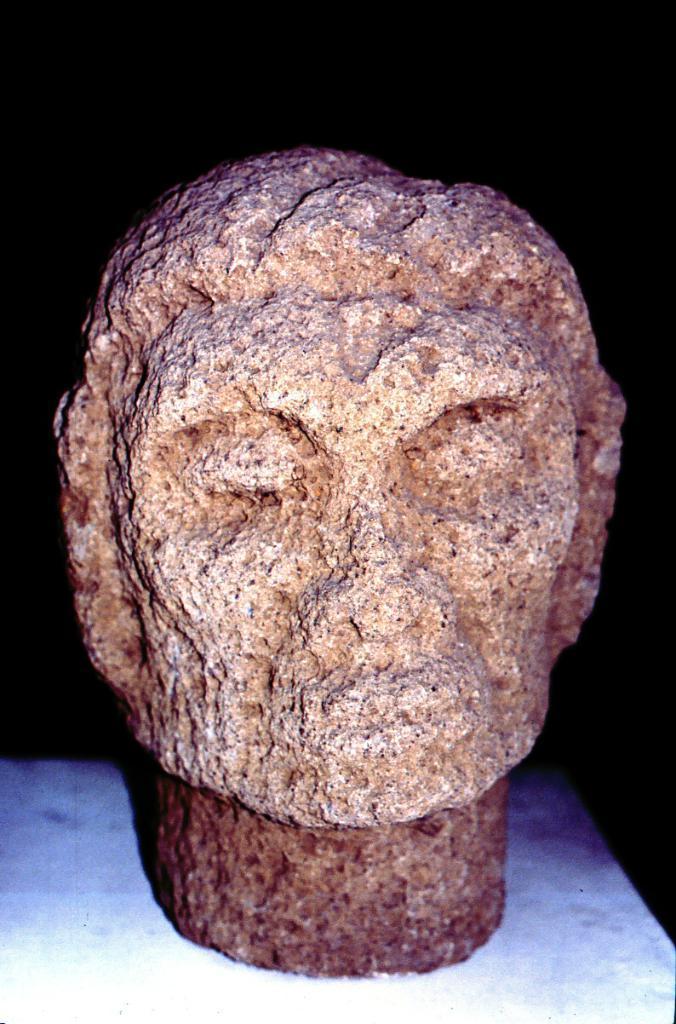Could you give a brief overview of what you see in this image? In this image, we can see a statue carved on the stone, it is kept on a white object, there is a dark background. 